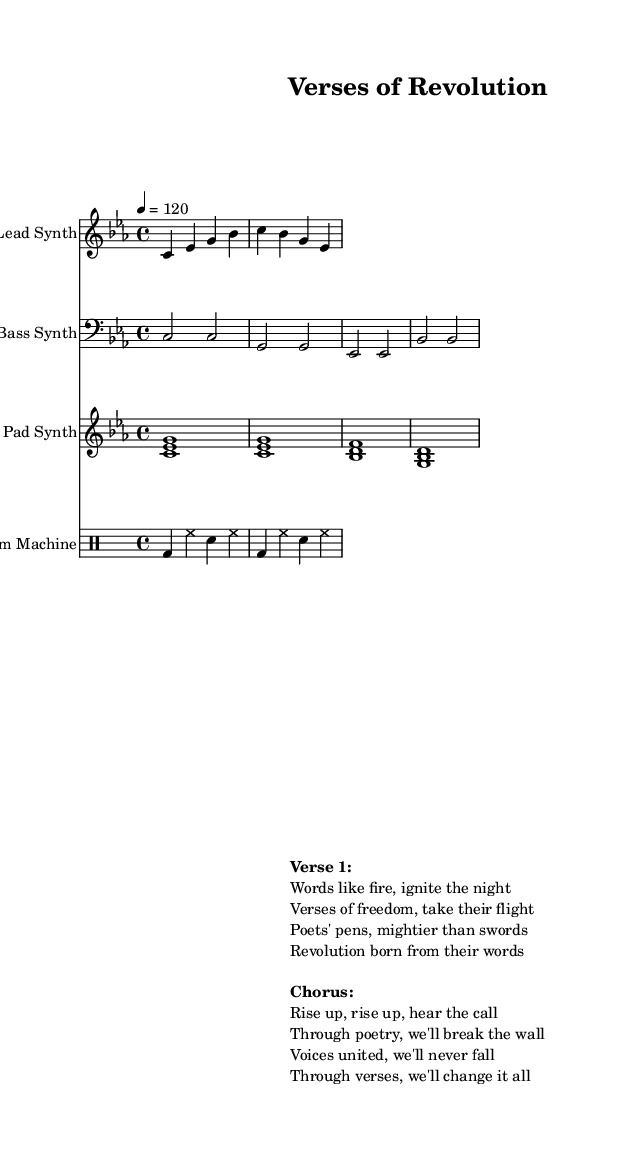What is the key signature of this music? The key signature is indicated by the absence of sharps or flats in the music, suggesting the music is written in C minor, which has three flats (B♭, E♭, and A♭). However, since the piece is specifically notated in the C minor key signature, it includes those flats in the context of the music.
Answer: C minor What is the time signature of the piece? The time signature is typically shown at the beginning of the music. In this case, it is written in 4/4, indicating four beats in each measure, and the quarter note receives one beat.
Answer: 4/4 What is the tempo marking given in this score? The tempo marking is indicated as "4 = 120," which means that a quarter note is set to play at a speed of 120 beats per minute.
Answer: 120 How many measures are in the lead synth part? By counting the individual phrases and the bars shown in the lead synth notation, we see that there are a total of 4 measures in the lead synth part.
Answer: 4 Which type of synthesizer is designated as the bass instrument? In the score, the specific staff designated for the bass line is labeled clearly as "Bass Synth," indicating that it is a bass synthesizer part.
Answer: Bass Synth What specific theme is expressed in the lyrics? The lyrics indicate a revolutionary theme, focusing on poetry as a catalyst for freedom and empowerment, which is evident in phrases like "Poets' pens, mightier than swords."
Answer: Revolution 